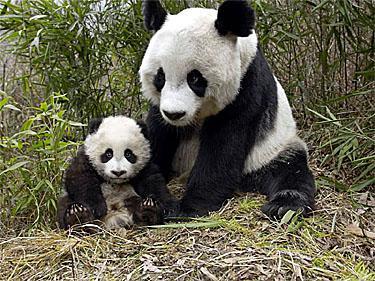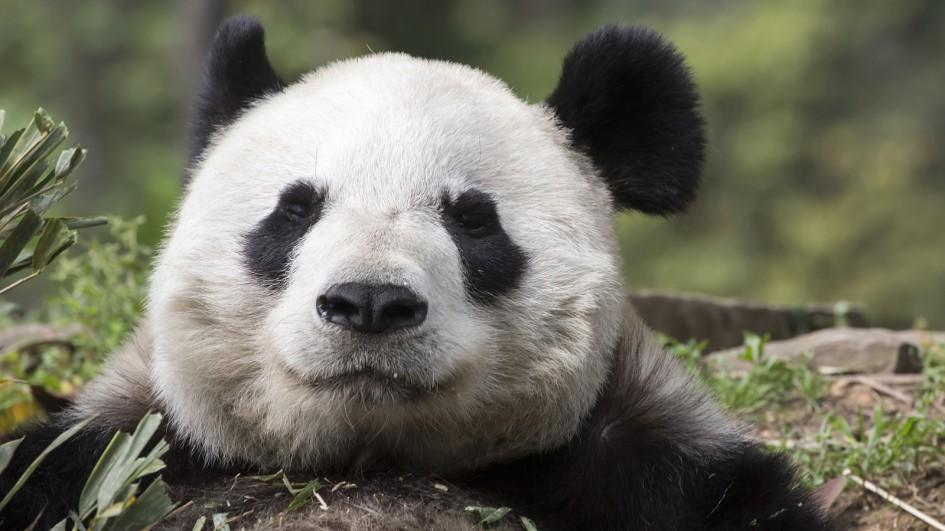The first image is the image on the left, the second image is the image on the right. For the images displayed, is the sentence "Only one image shows a panda munching on some type of foliage." factually correct? Answer yes or no. No. The first image is the image on the left, the second image is the image on the right. Evaluate the accuracy of this statement regarding the images: "One of the pandas is eating on bamboo.". Is it true? Answer yes or no. No. 